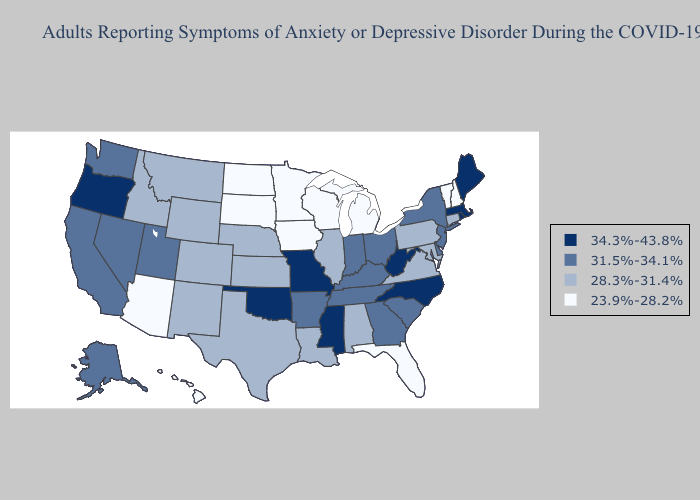What is the value of Florida?
Write a very short answer. 23.9%-28.2%. Which states hav the highest value in the Northeast?
Concise answer only. Maine, Massachusetts, Rhode Island. Name the states that have a value in the range 34.3%-43.8%?
Short answer required. Maine, Massachusetts, Mississippi, Missouri, North Carolina, Oklahoma, Oregon, Rhode Island, West Virginia. Does Minnesota have a lower value than Vermont?
Be succinct. No. Name the states that have a value in the range 23.9%-28.2%?
Be succinct. Arizona, Florida, Hawaii, Iowa, Michigan, Minnesota, New Hampshire, North Dakota, South Dakota, Vermont, Wisconsin. What is the lowest value in states that border Georgia?
Quick response, please. 23.9%-28.2%. Does New Jersey have the same value as Tennessee?
Be succinct. Yes. Which states have the lowest value in the USA?
Concise answer only. Arizona, Florida, Hawaii, Iowa, Michigan, Minnesota, New Hampshire, North Dakota, South Dakota, Vermont, Wisconsin. Among the states that border Florida , which have the highest value?
Quick response, please. Georgia. Among the states that border Illinois , does Missouri have the highest value?
Concise answer only. Yes. Name the states that have a value in the range 23.9%-28.2%?
Be succinct. Arizona, Florida, Hawaii, Iowa, Michigan, Minnesota, New Hampshire, North Dakota, South Dakota, Vermont, Wisconsin. Name the states that have a value in the range 23.9%-28.2%?
Concise answer only. Arizona, Florida, Hawaii, Iowa, Michigan, Minnesota, New Hampshire, North Dakota, South Dakota, Vermont, Wisconsin. What is the lowest value in the West?
Short answer required. 23.9%-28.2%. Which states have the highest value in the USA?
Short answer required. Maine, Massachusetts, Mississippi, Missouri, North Carolina, Oklahoma, Oregon, Rhode Island, West Virginia. Which states have the lowest value in the Northeast?
Be succinct. New Hampshire, Vermont. 